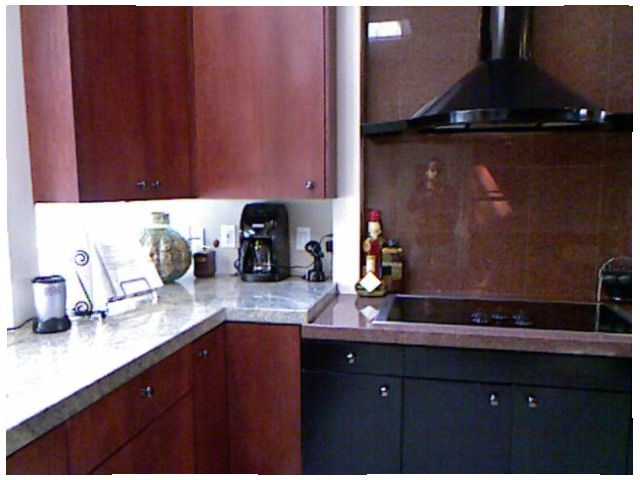<image>
Can you confirm if the coffee maker is next to the blender? No. The coffee maker is not positioned next to the blender. They are located in different areas of the scene. Is there a wall behind the chimney? Yes. From this viewpoint, the wall is positioned behind the chimney, with the chimney partially or fully occluding the wall. Is there a vent above the stove? Yes. The vent is positioned above the stove in the vertical space, higher up in the scene. Is the vent above the stovetop? Yes. The vent is positioned above the stovetop in the vertical space, higher up in the scene. Is the coffee maker in the cabinet? No. The coffee maker is not contained within the cabinet. These objects have a different spatial relationship. 